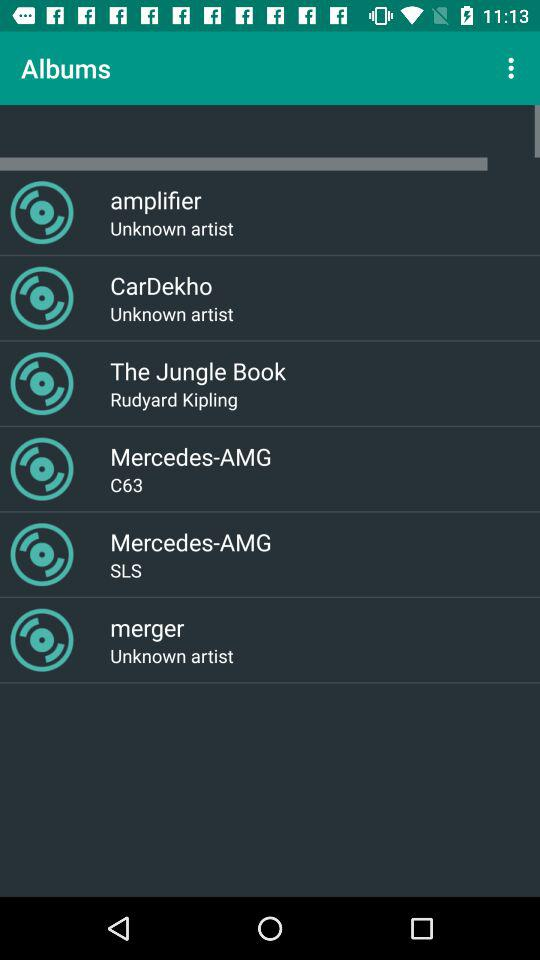How many items have the artist "Unknown artist"?
Answer the question using a single word or phrase. 3 